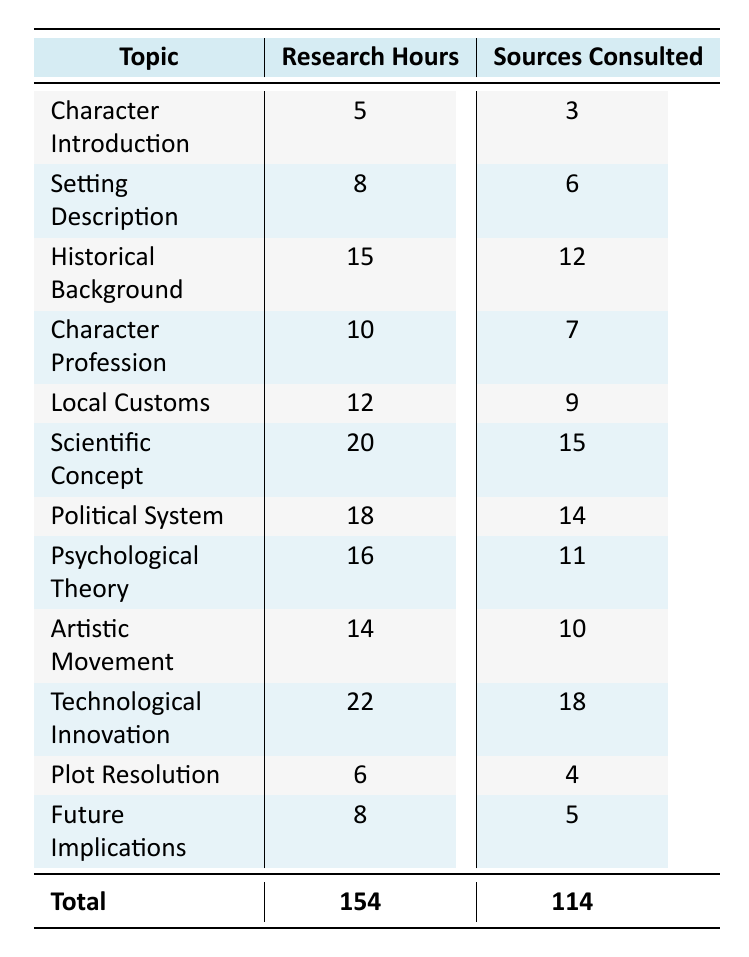What chapter required the most research hours? From the table, the chapter with the highest research hours is "Technological Innovation," which has 22 hours.
Answer: Technological Innovation How many sources were consulted for Scientific Concept? Looking at the row for "Scientific Concept," it shows that 15 sources were consulted.
Answer: 15 What is the total number of research hours spent across all chapters? To find the total, we can sum all the research hours: 5 + 8 + 15 + 10 + 12 + 20 + 18 + 16 + 14 + 22 + 6 + 8 = 154.
Answer: 154 Are more sources generally consulted for chapters that require more research hours? To answer this, we can compare the trend in the table. For instance, "Technological Innovation" has both the highest hours and sources consulted (22 and 18), while "Character Introduction," the lowest in hours (5), has the least sources consulted (3). Thus, it suggests a positive correlation overall.
Answer: Yes What is the average number of sources consulted across all chapters? We first need to calculate the total sources consulted, which is 114. Then divide by the number of chapters, which is 12: 114/12 = 9.5. Thus, the average is 9.5.
Answer: 9.5 How many chapters had more than 15 research hours? From the table, the chapters with more than 15 research hours are "Historical Background," "Scientific Concept," "Political System," "Psychological Theory," "Technological Innovation," totaling five chapters.
Answer: 5 Which chapter focused on Local Customs? The table clearly shows that "Local Customs" is the topic in "Chapter 4."
Answer: Chapter 4 What is the difference in research hours between Character Introduction and Plot Resolution? For "Character Introduction," the research hours are 5, and for "Plot Resolution," they are 6. The difference is 6 - 5 = 1 hour.
Answer: 1 hour How many chapters focused on characters or character-related topics? The chapters with character-related topics are "Character Introduction," "Character Profession," and "Plot Resolution," making a total of three chapters.
Answer: 3 